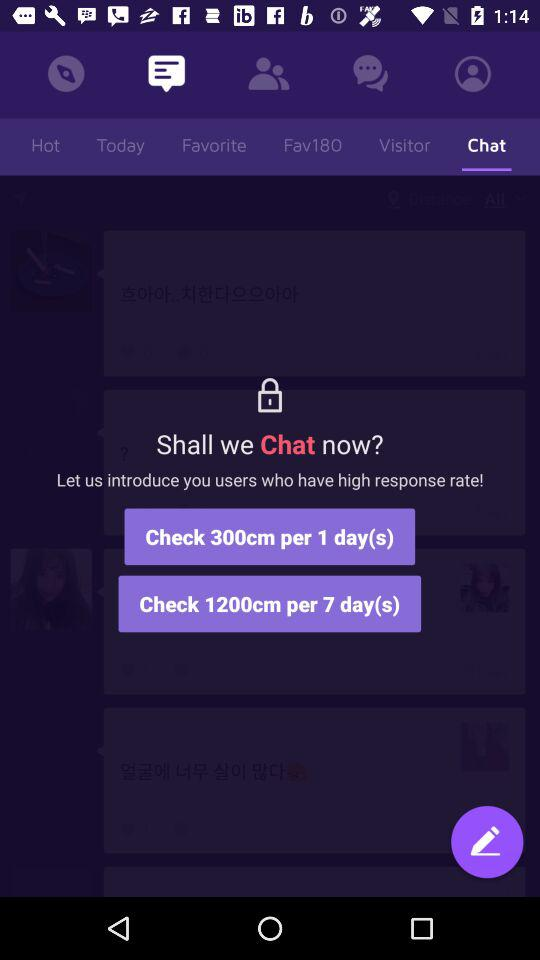How many more days does the 1200cm per 7 day plan have than the 300cm per 1 day plan?
Answer the question using a single word or phrase. 6 